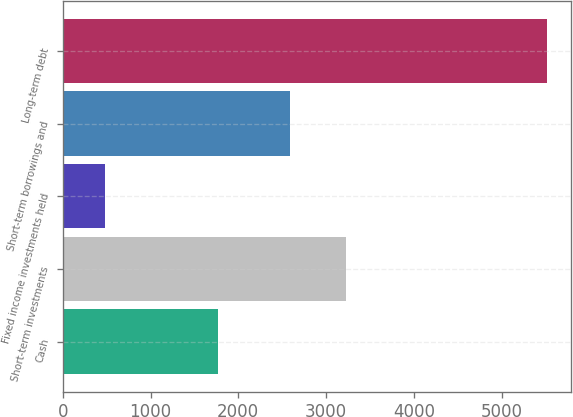Convert chart. <chart><loc_0><loc_0><loc_500><loc_500><bar_chart><fcel>Cash<fcel>Short-term investments<fcel>Fixed income investments held<fcel>Short-term borrowings and<fcel>Long-term debt<nl><fcel>1764<fcel>3226<fcel>484<fcel>2595<fcel>5517<nl></chart> 